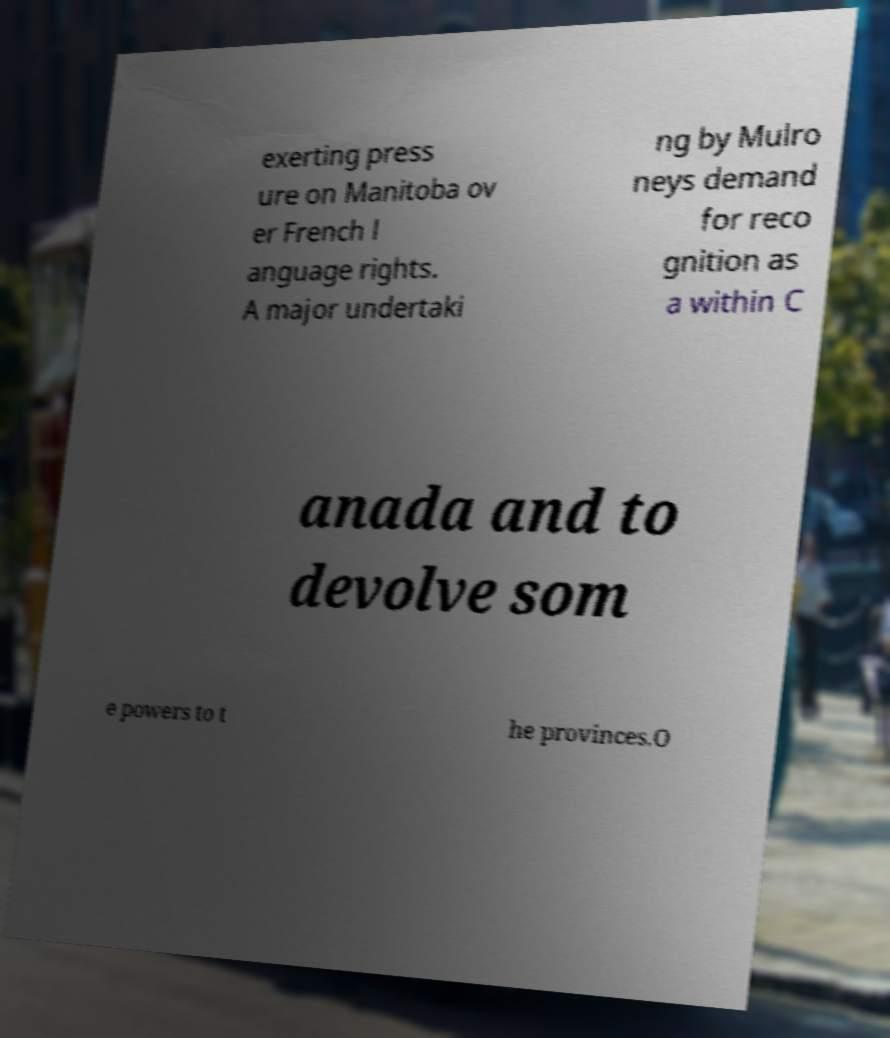Can you accurately transcribe the text from the provided image for me? exerting press ure on Manitoba ov er French l anguage rights. A major undertaki ng by Mulro neys demand for reco gnition as a within C anada and to devolve som e powers to t he provinces.O 